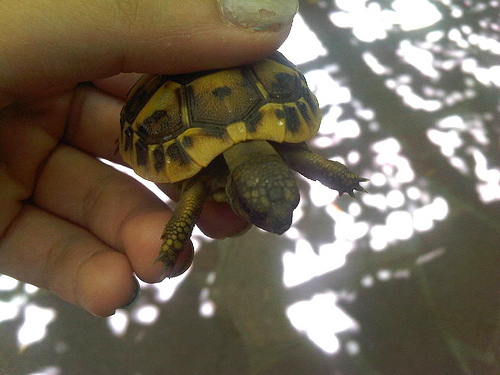<image>
Is the turtle behind the fingers? No. The turtle is not behind the fingers. From this viewpoint, the turtle appears to be positioned elsewhere in the scene. 